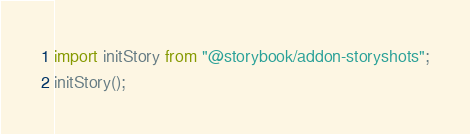<code> <loc_0><loc_0><loc_500><loc_500><_JavaScript_>import initStory from "@storybook/addon-storyshots";
initStory();
</code> 